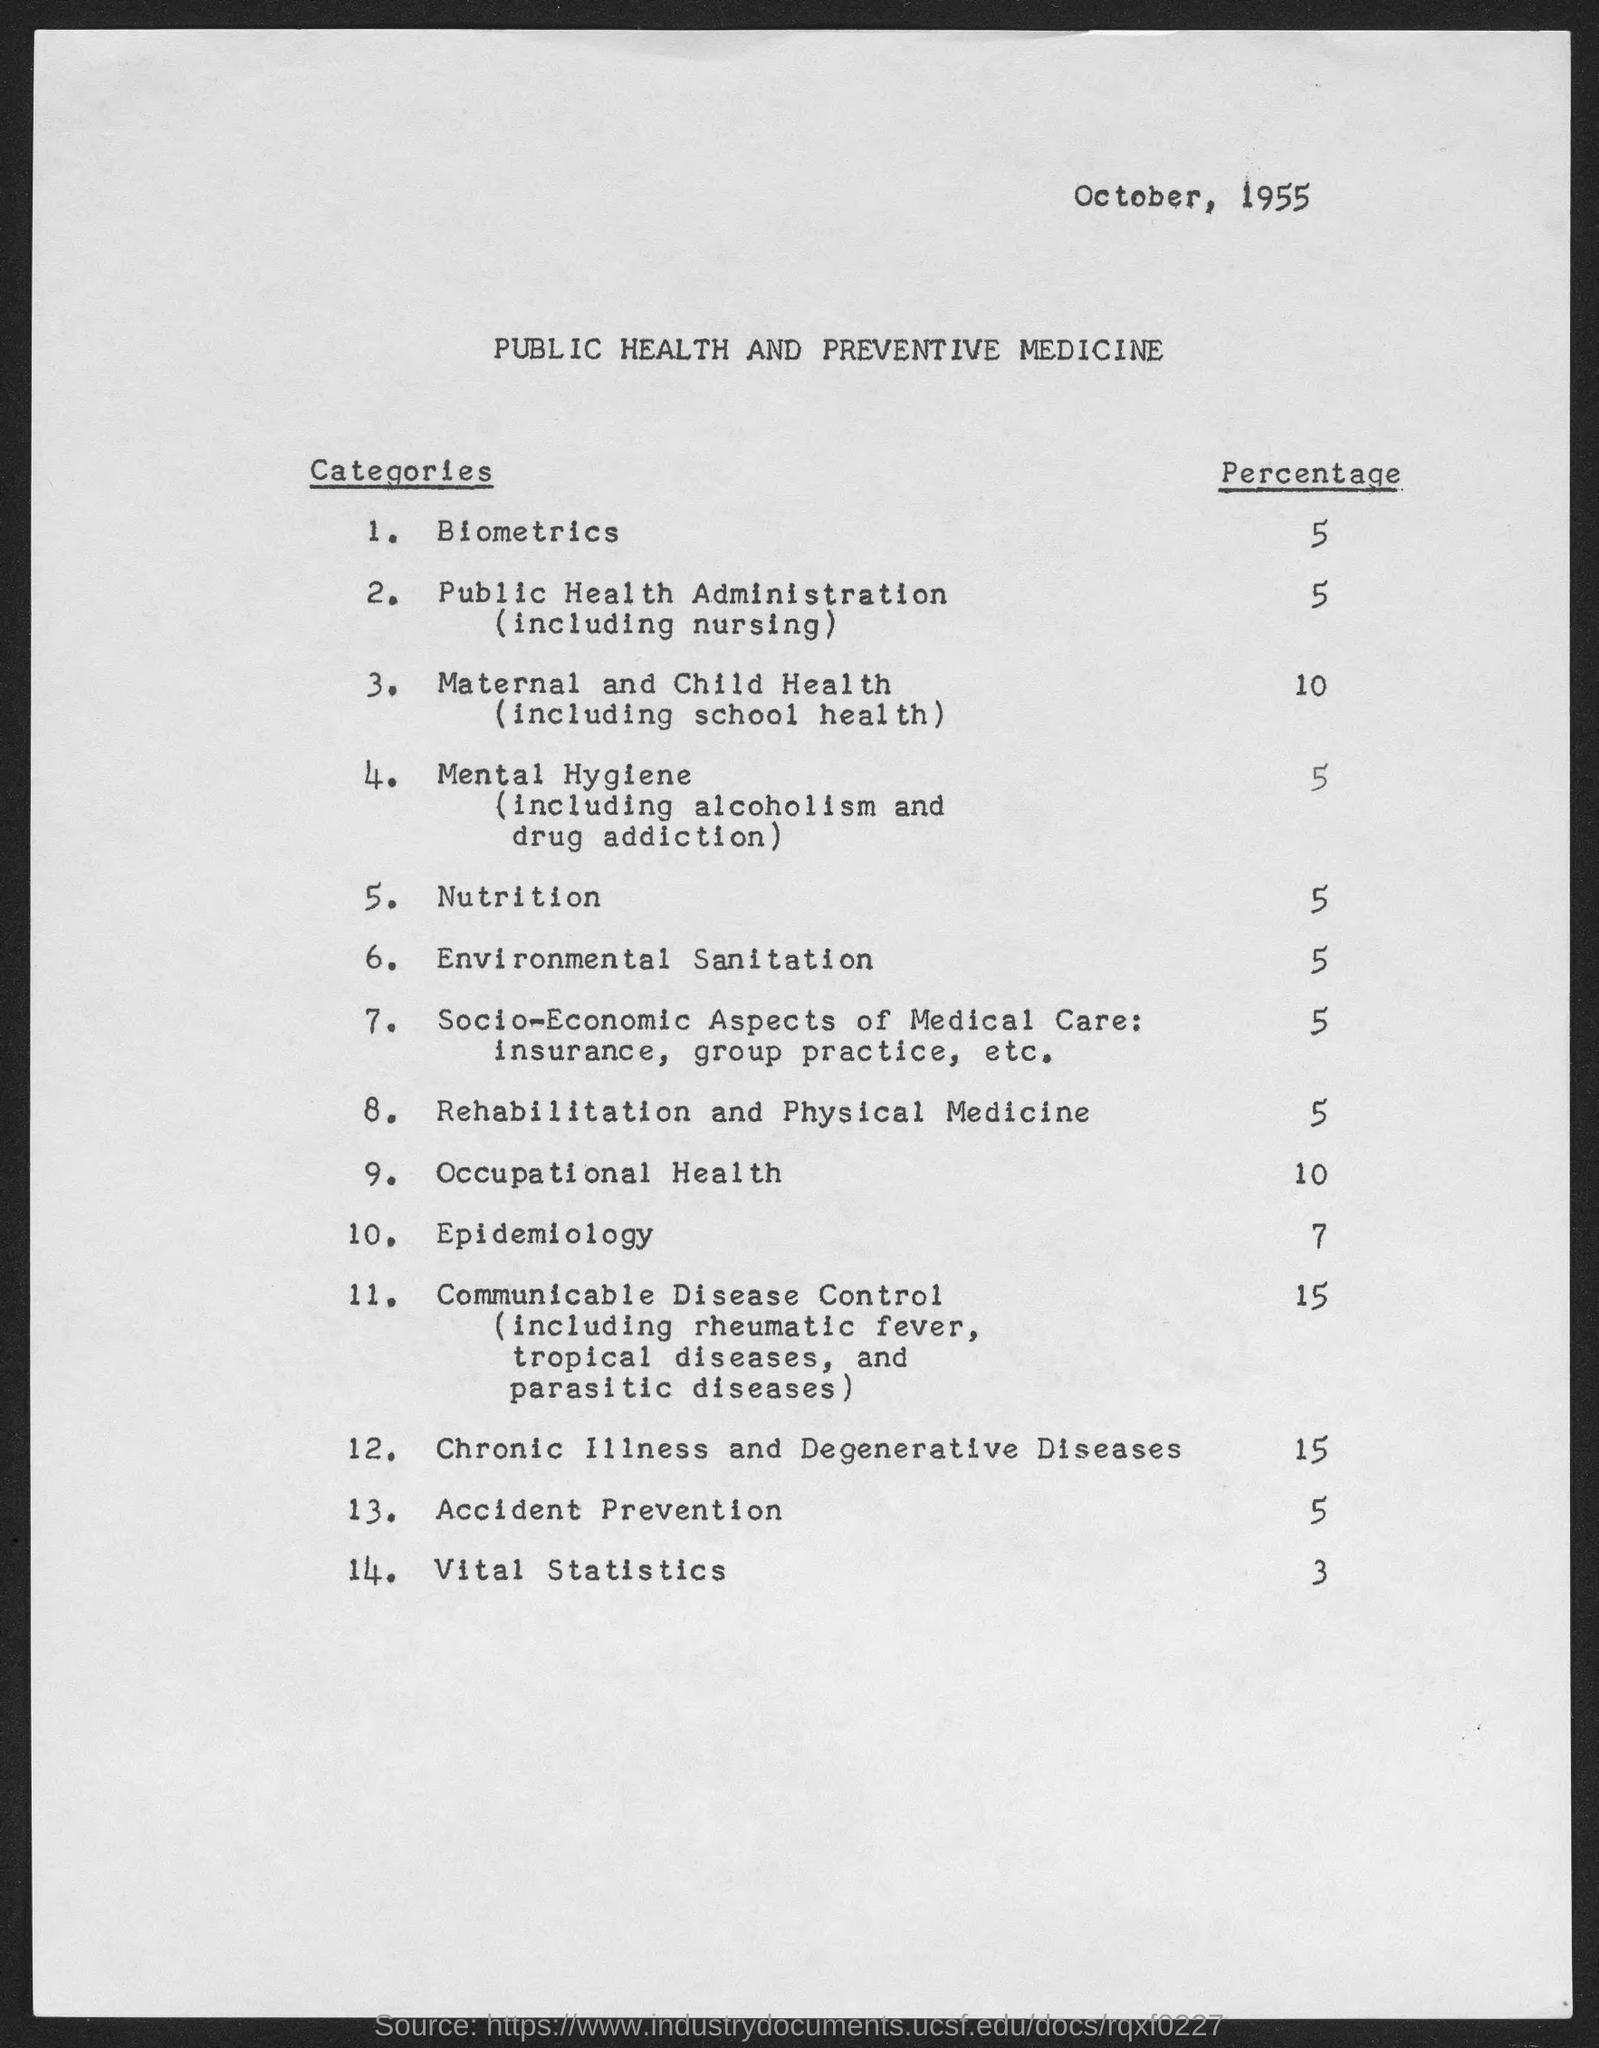What is the month and year at top of the page?
Your answer should be very brief. October, 1955. What is the percentage of biometrics?
Your answer should be compact. 5. What is the percentage of public health administration ( including nursing)?
Offer a terse response. 5%. What is the percentage of maternal and child health( including school health ) ?
Offer a very short reply. 10%. What is the percentage of mental hygiene ( including alcoholism and drug addiction ?
Make the answer very short. 5%. What is the percentage of nutrition ?
Your answer should be compact. 5%. What is the percentage of accident prevention ?
Your answer should be compact. 5. What is the percentage of environmental sanitation ?
Ensure brevity in your answer.  5. What is the percentage of occupational health ?
Your answer should be compact. 10. What is the percentage of epidemiology ?
Make the answer very short. 7%. 